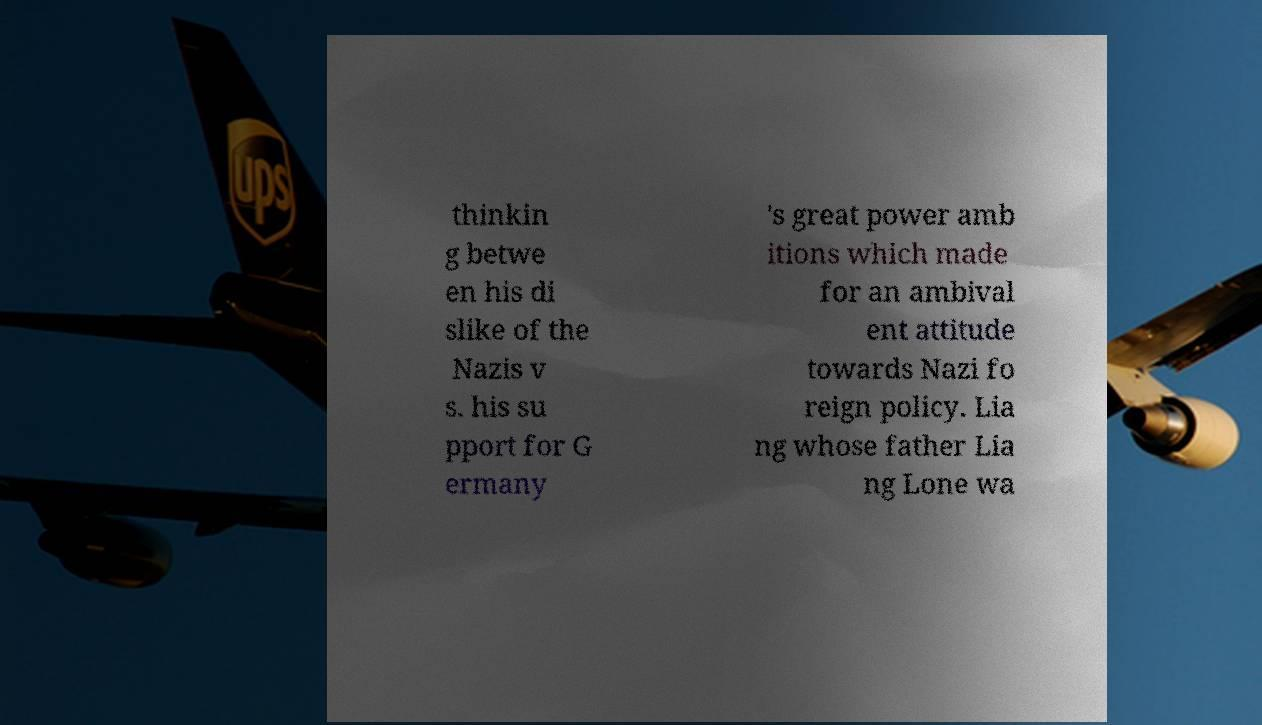Please read and relay the text visible in this image. What does it say? thinkin g betwe en his di slike of the Nazis v s. his su pport for G ermany 's great power amb itions which made for an ambival ent attitude towards Nazi fo reign policy. Lia ng whose father Lia ng Lone wa 